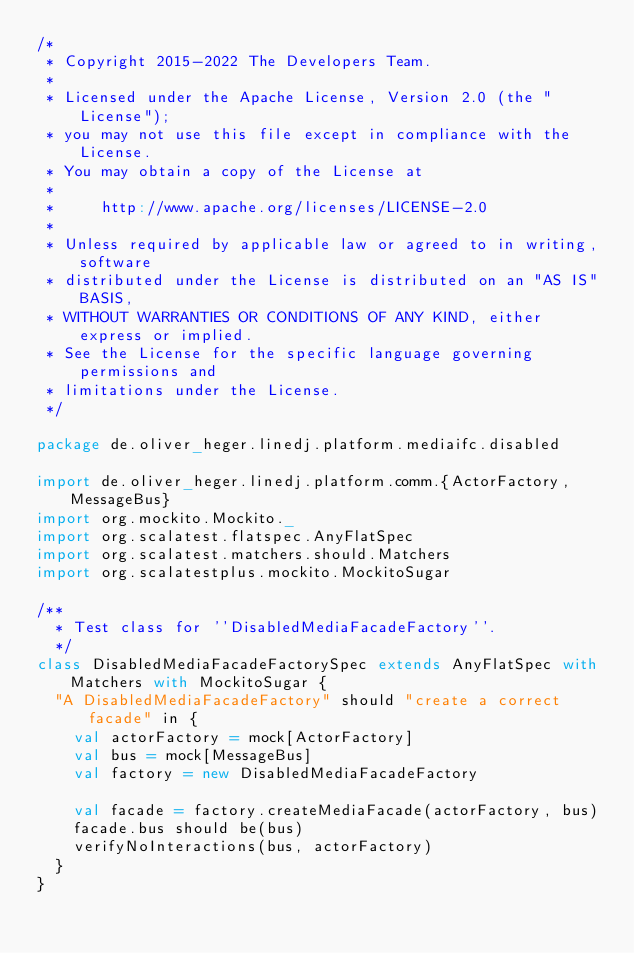Convert code to text. <code><loc_0><loc_0><loc_500><loc_500><_Scala_>/*
 * Copyright 2015-2022 The Developers Team.
 *
 * Licensed under the Apache License, Version 2.0 (the "License");
 * you may not use this file except in compliance with the License.
 * You may obtain a copy of the License at
 *
 *     http://www.apache.org/licenses/LICENSE-2.0
 *
 * Unless required by applicable law or agreed to in writing, software
 * distributed under the License is distributed on an "AS IS" BASIS,
 * WITHOUT WARRANTIES OR CONDITIONS OF ANY KIND, either express or implied.
 * See the License for the specific language governing permissions and
 * limitations under the License.
 */

package de.oliver_heger.linedj.platform.mediaifc.disabled

import de.oliver_heger.linedj.platform.comm.{ActorFactory, MessageBus}
import org.mockito.Mockito._
import org.scalatest.flatspec.AnyFlatSpec
import org.scalatest.matchers.should.Matchers
import org.scalatestplus.mockito.MockitoSugar

/**
  * Test class for ''DisabledMediaFacadeFactory''.
  */
class DisabledMediaFacadeFactorySpec extends AnyFlatSpec with Matchers with MockitoSugar {
  "A DisabledMediaFacadeFactory" should "create a correct facade" in {
    val actorFactory = mock[ActorFactory]
    val bus = mock[MessageBus]
    val factory = new DisabledMediaFacadeFactory

    val facade = factory.createMediaFacade(actorFactory, bus)
    facade.bus should be(bus)
    verifyNoInteractions(bus, actorFactory)
  }
}
</code> 